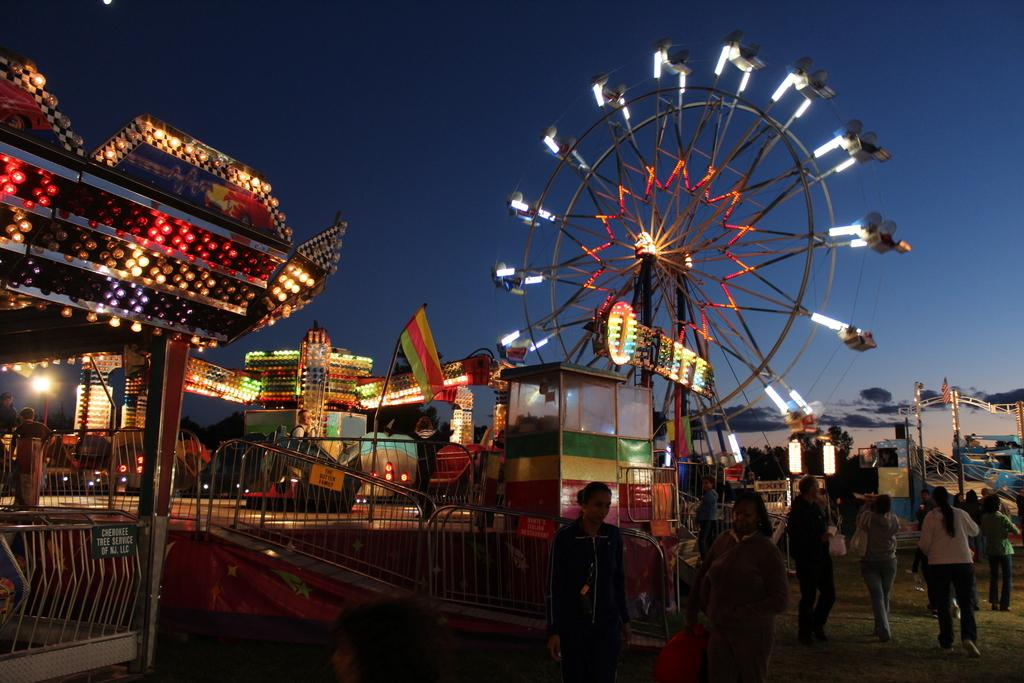What is happening in the image? There is an exhibition in the image. What types of attractions can be found at the exhibition? There are rides at the exhibition, including a giant wheel. Can you describe the people in the image? There are other people in the image, likely attending the exhibition. What might be used to control the flow of people or direct them in the image? There are barricades in the image. What verse is being recited by the self in the image? There is no self or verse present in the image; it features an exhibition with rides and other people. 